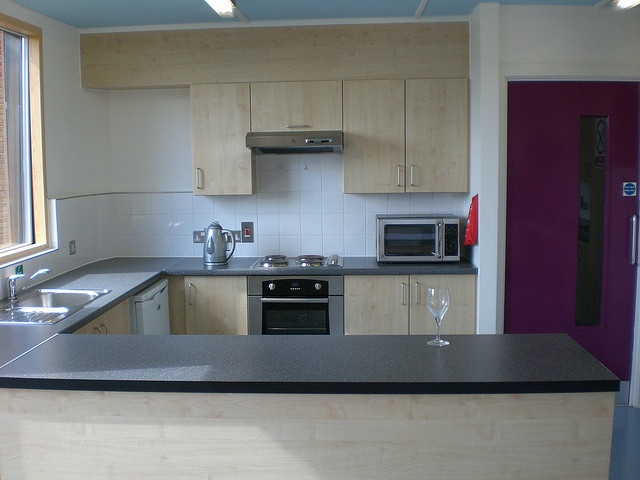Describe the objects in this image and their specific colors. I can see refrigerator in gray, black, and navy tones, oven in gray, black, darkgray, and darkblue tones, microwave in gray, black, and darkgray tones, sink in gray, white, and darkgray tones, and wine glass in gray and lightgray tones in this image. 